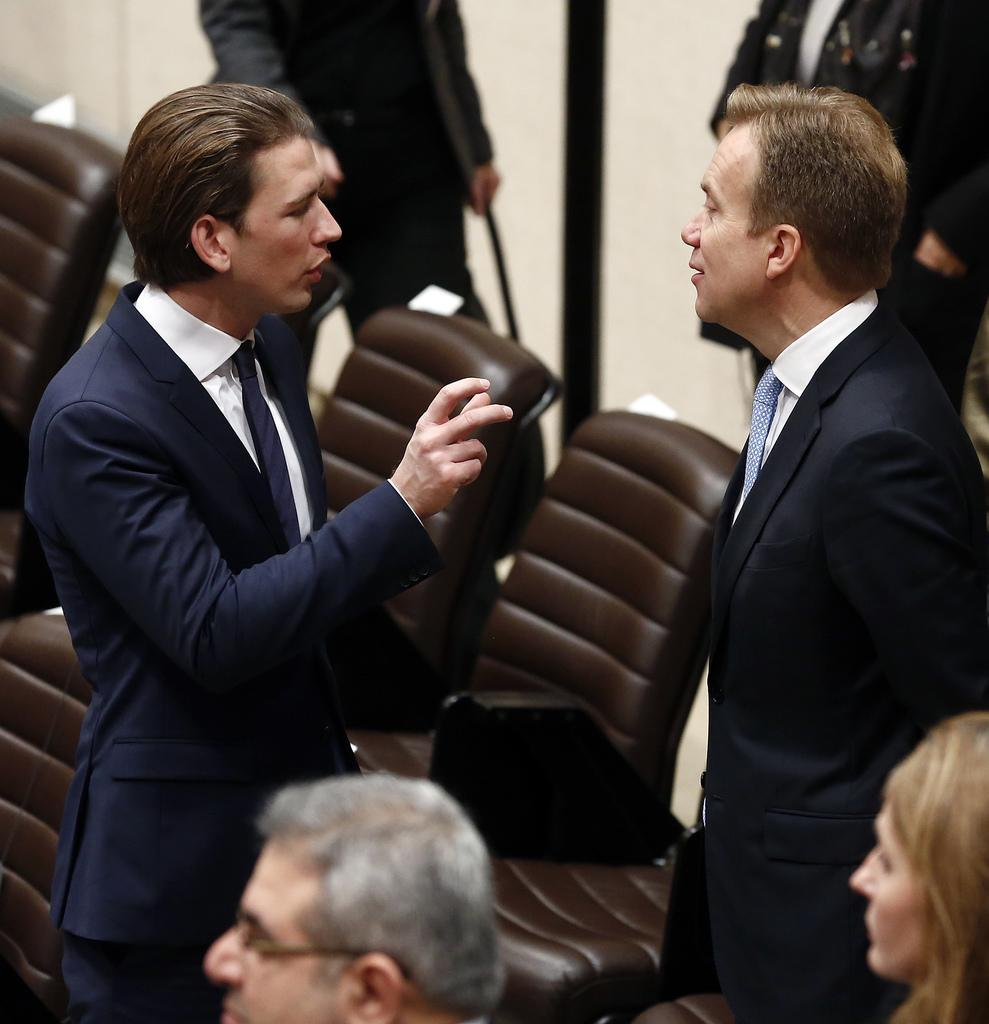How many men are present in the image? There are two men standing in the image. What are the two men doing in the image? The two men are speaking to each other. Are there any other people present in the image besides the two men? Yes, there are other people standing in the image. What type of pollution can be seen in the image? There is no pollution present in the image. How many cats are visible in the image? There are no cats present in the image. 